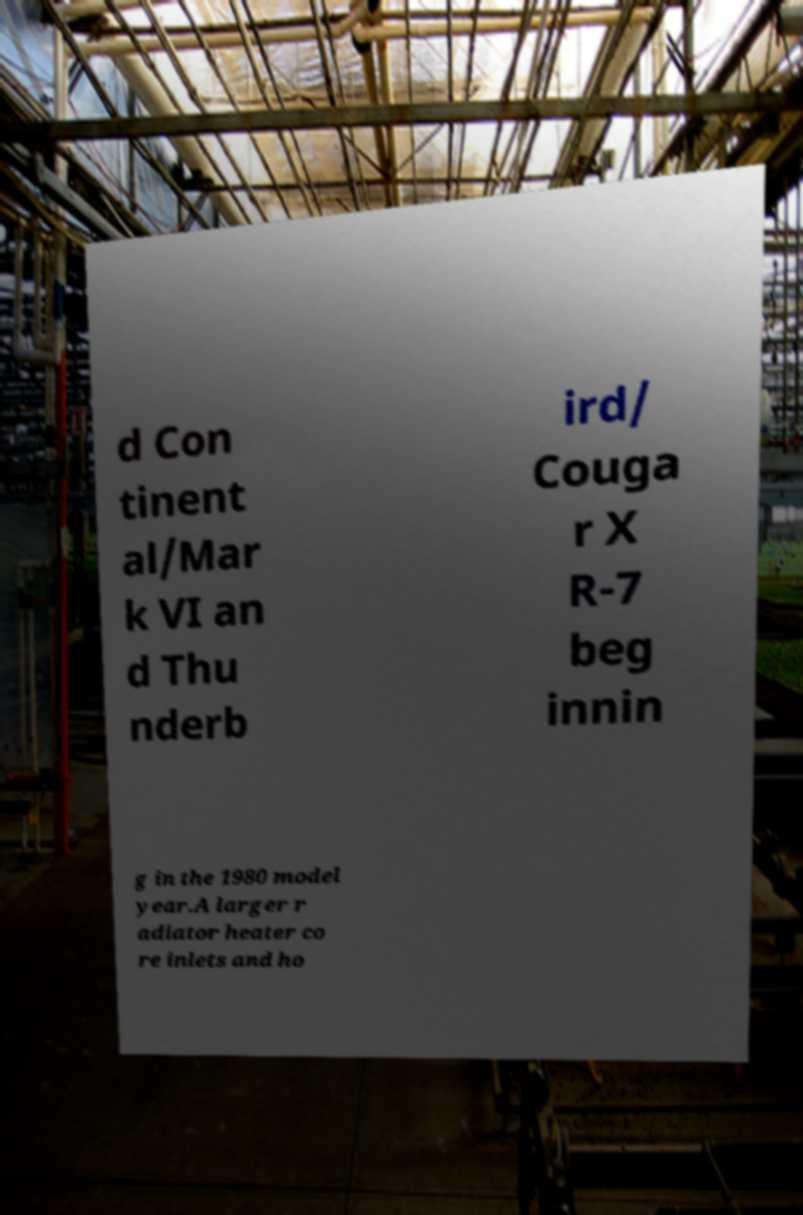Can you accurately transcribe the text from the provided image for me? d Con tinent al/Mar k VI an d Thu nderb ird/ Couga r X R-7 beg innin g in the 1980 model year.A larger r adiator heater co re inlets and ho 